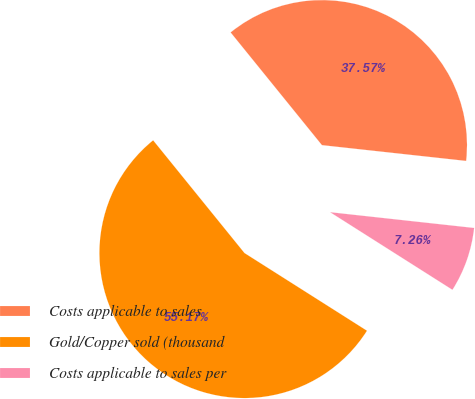Convert chart. <chart><loc_0><loc_0><loc_500><loc_500><pie_chart><fcel>Costs applicable to sales<fcel>Gold/Copper sold (thousand<fcel>Costs applicable to sales per<nl><fcel>37.57%<fcel>55.16%<fcel>7.26%<nl></chart> 